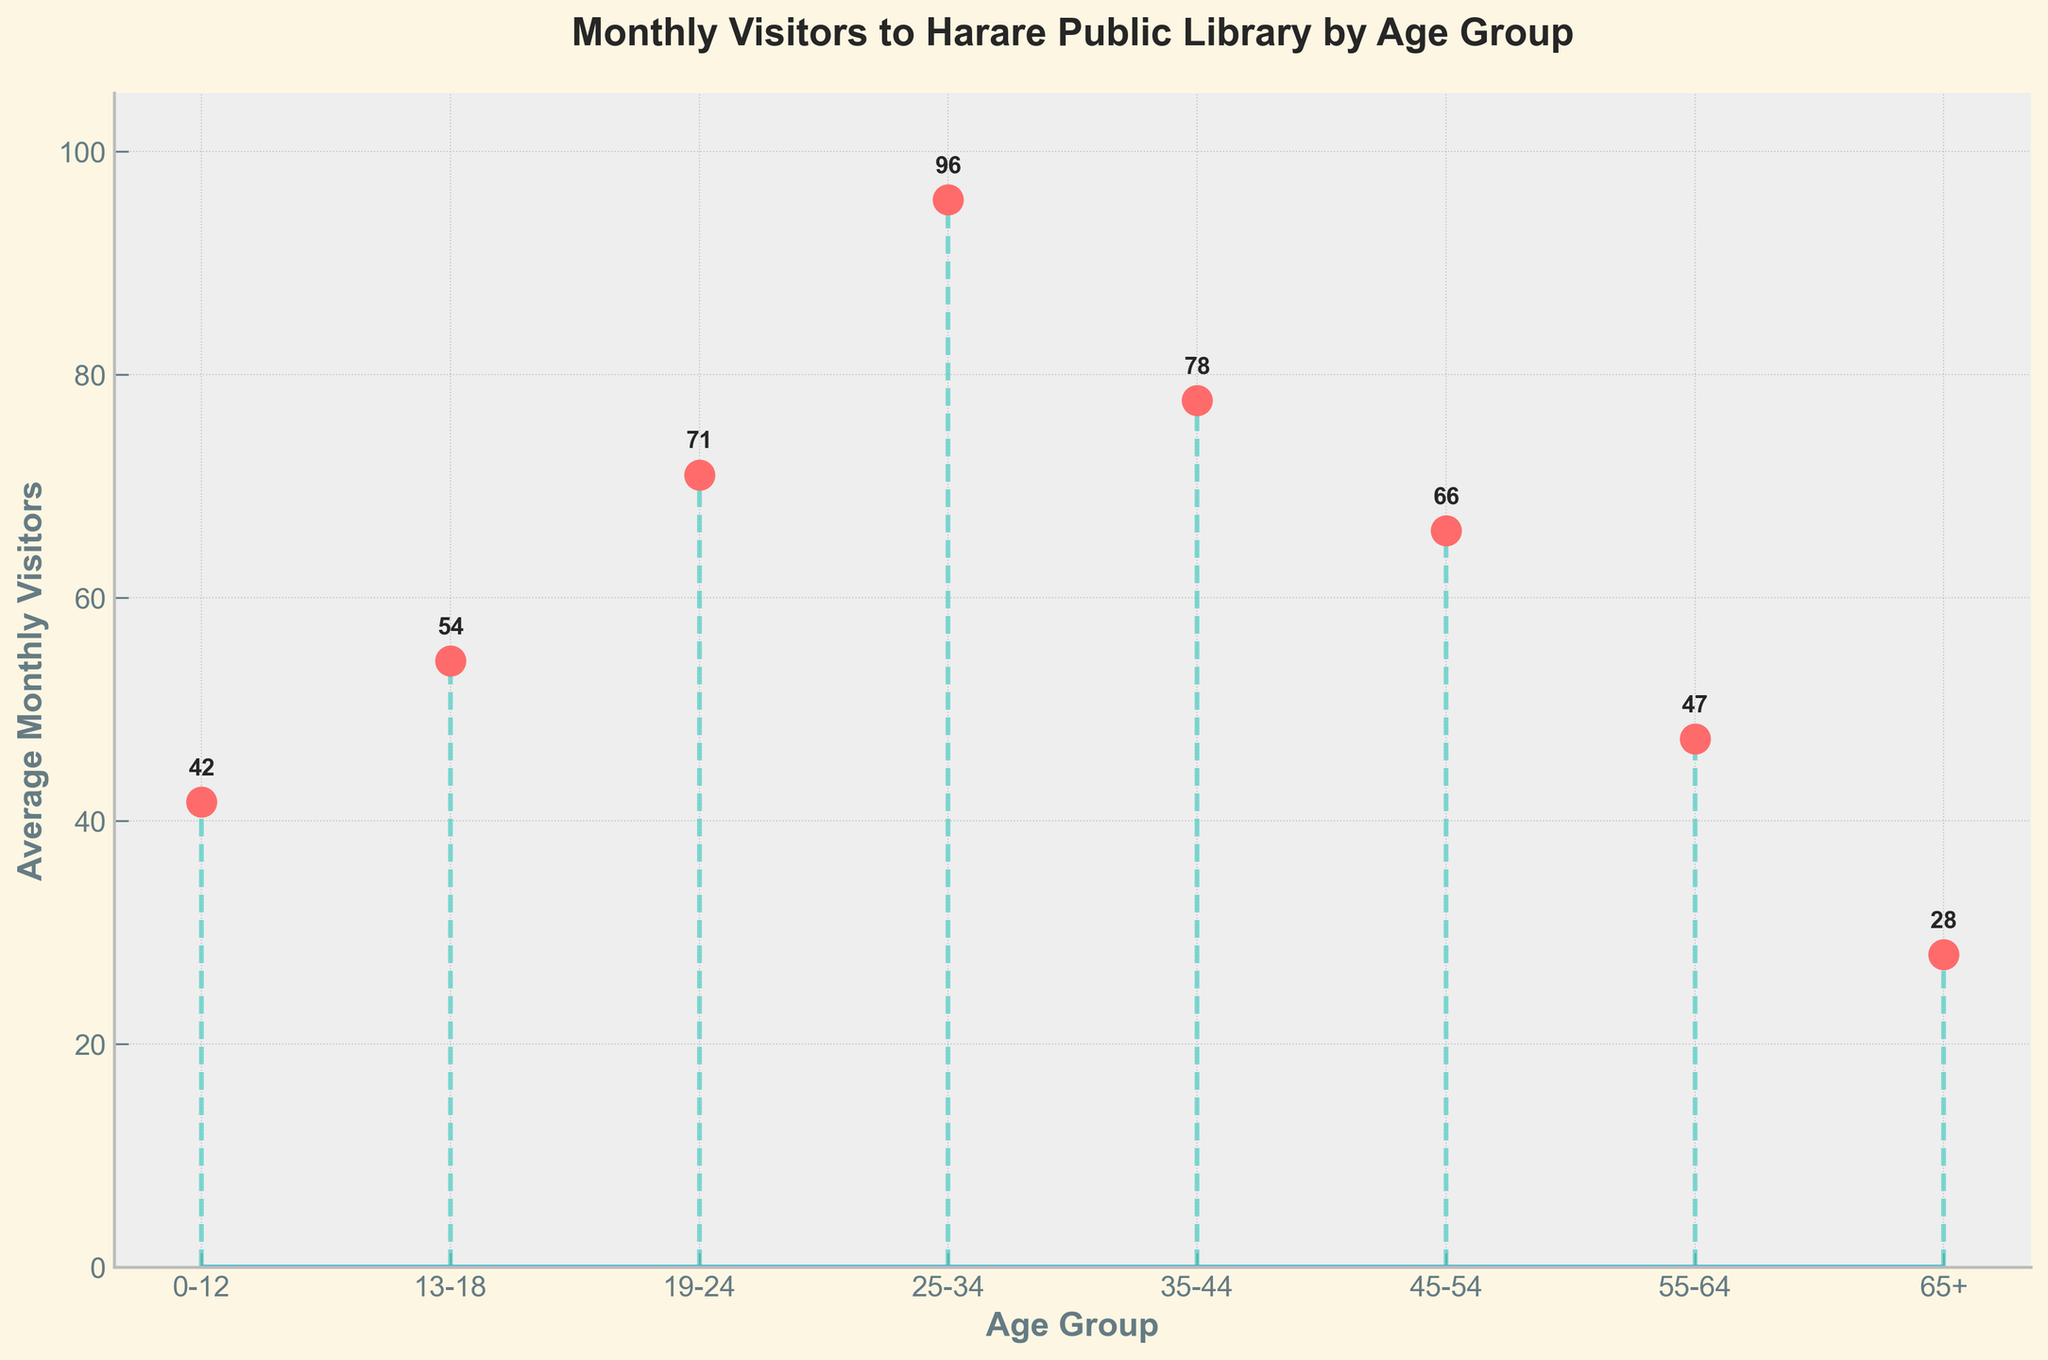What's the title of the figure? The title is clearly displayed at the top of the figure. It reads "Monthly Visitors to Harare Public Library by Age Group".
Answer: Monthly Visitors to Harare Public Library by Age Group What does the x-axis represent? The x-axis labels the different age groups. This can be identified by reading the labels along the horizontal axis.
Answer: Age Group What does the y-axis represent? The y-axis shows the average monthly visitors. This is indicated by the label on the vertical axis.
Answer: Average Monthly Visitors Which age group has the highest average number of visitors? By inspecting the stem height for each age group, the 25-34 group has the highest stem, indicating it has the most visitors.
Answer: 25-34 What is the average number of visitors for the 0-12 age group? By reading the stem height value annotated next to the data point, the average number for the 0-12 age group is 41.67.
Answer: 42 Compare the average number of visitors between the 19-24 and 35-44 age groups. Which age group has more visitors, and by how much? The 19-24 age group has an average of 71 visitors, while the 35-44 age group has an average of 77. The difference is 77 - 71 = 6.
Answer: 35-44, by 6 visitors What is the difference in the average number of visitors between the 45-54 and 65+ age groups? The average for the 45-54 age group is 66, while for the 65+ age group, it is 28. The difference is 66 - 28 = 38.
Answer: 38 What is the overall trend in average monthly visitors across the age groups? By examining the pattern in the stem heights from left to right, there’s an initial increase, a peak in the 25-34 age group, and then a gradual decrease as age increases.
Answer: Increase to peak, then decrease Calculate the total average monthly visitors for all age groups combined. Sum all the provided average values: 42 (0-12) + 54 (13-18) + 71 (19-24) + 96 (25-34) + 77 (35-44) + 66 (45-54) + 47 (55-64) + 28 (65+) = 481.
Answer: 481 What color are the markers used in the plot? The markers, represented by circles at the end of the stems, are colored red. This is visible by observing the marker colors.
Answer: Red 